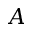Convert formula to latex. <formula><loc_0><loc_0><loc_500><loc_500>A</formula> 